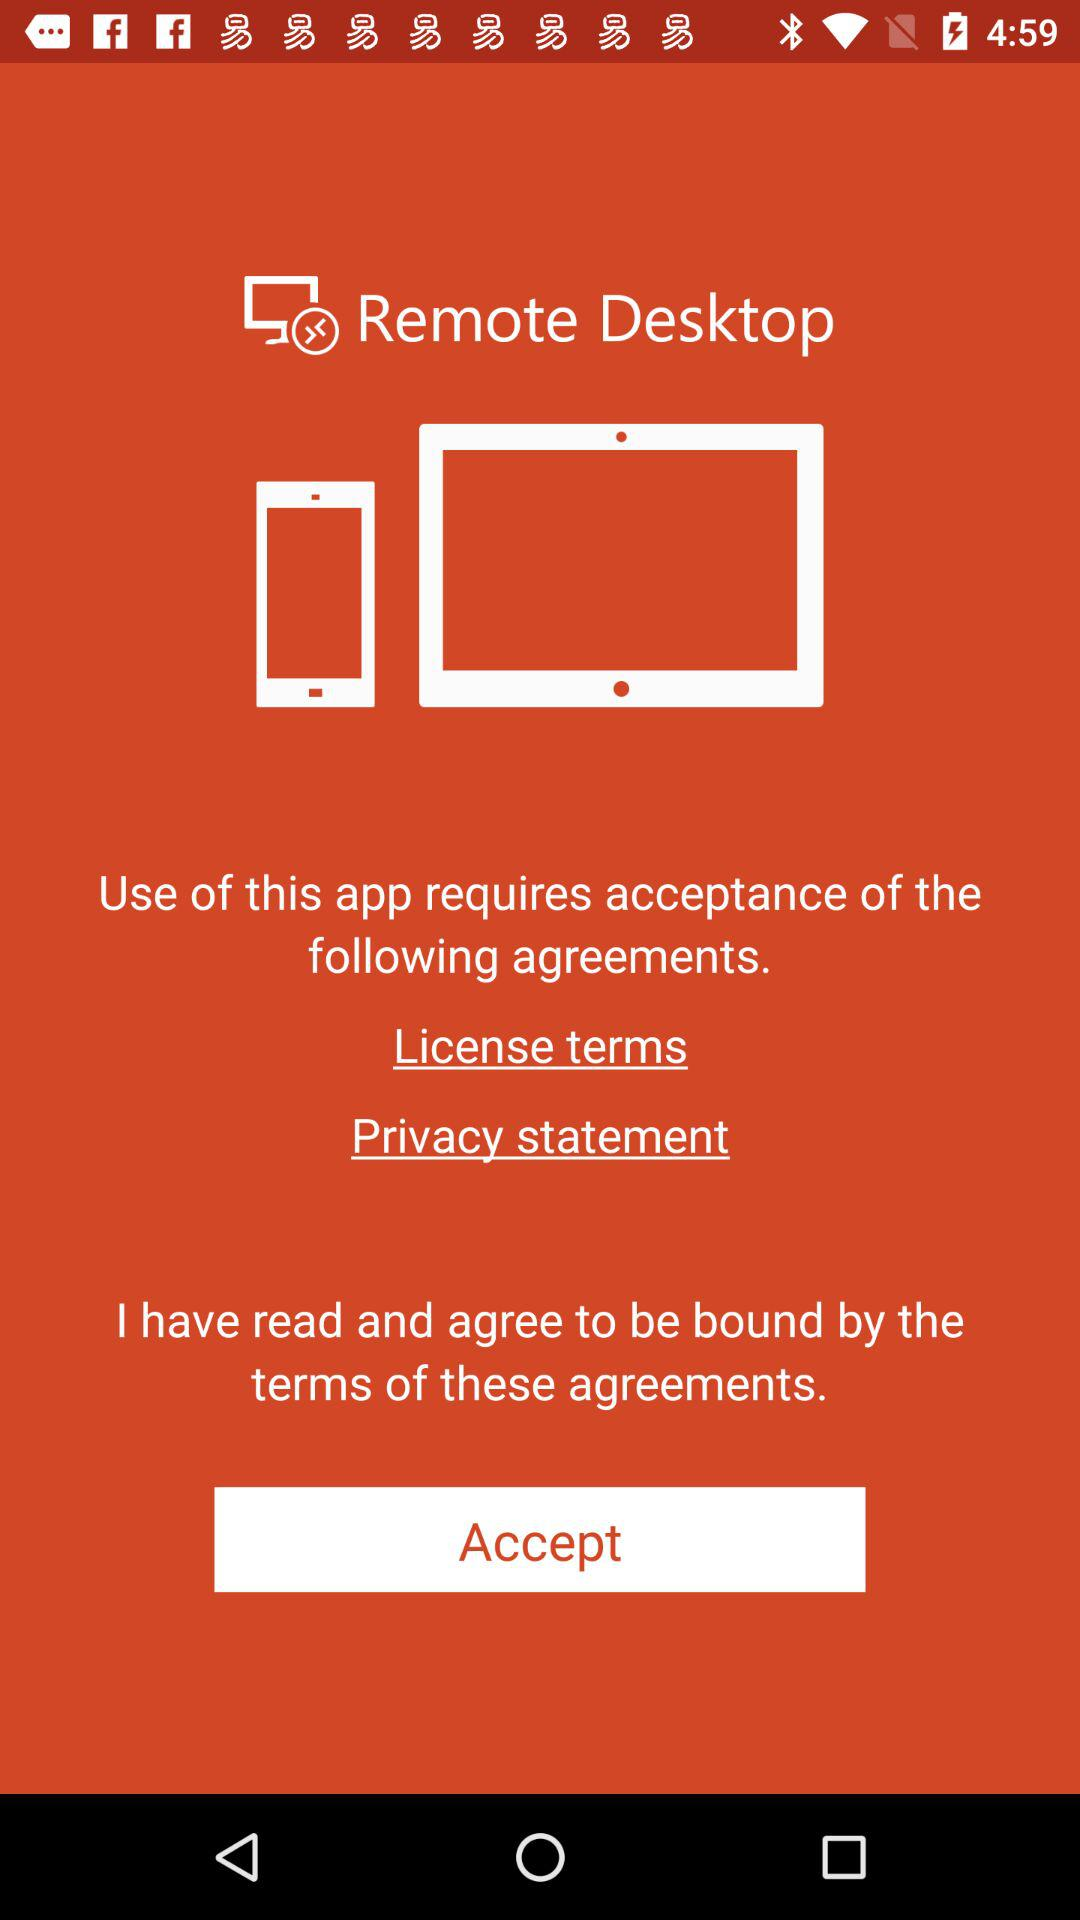What is the name of the application? The name of the application is "Remote Desktop". 